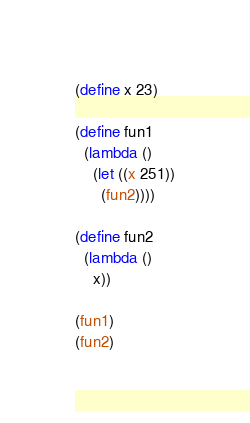Convert code to text. <code><loc_0><loc_0><loc_500><loc_500><_Scheme_>(define x 23)

(define fun1
  (lambda ()
    (let ((x 251))
      (fun2))))

(define fun2
  (lambda ()
    x))

(fun1)
(fun2)
</code> 